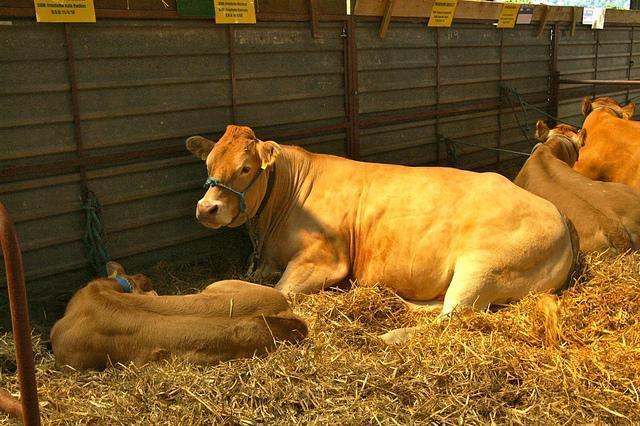How many calves are in the barn?
Give a very brief answer. 1. How many cows are in the photo?
Give a very brief answer. 4. 